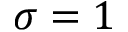<formula> <loc_0><loc_0><loc_500><loc_500>\sigma = 1</formula> 